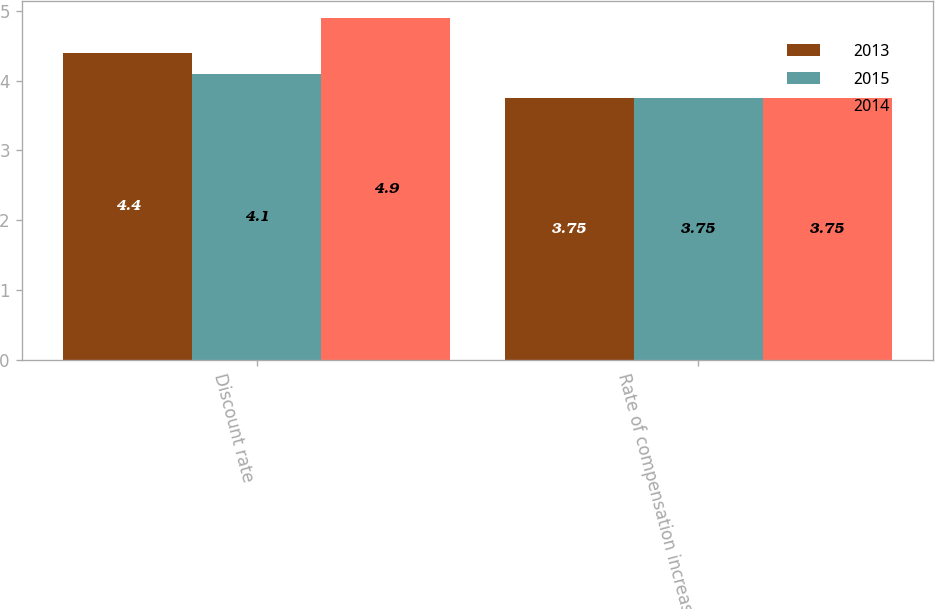<chart> <loc_0><loc_0><loc_500><loc_500><stacked_bar_chart><ecel><fcel>Discount rate<fcel>Rate of compensation increase<nl><fcel>2013<fcel>4.4<fcel>3.75<nl><fcel>2015<fcel>4.1<fcel>3.75<nl><fcel>2014<fcel>4.9<fcel>3.75<nl></chart> 